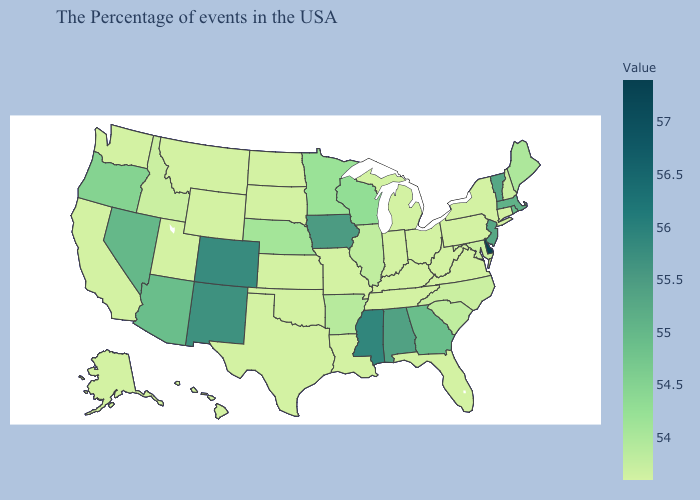Among the states that border Kansas , does Missouri have the highest value?
Write a very short answer. No. Among the states that border Delaware , does New Jersey have the lowest value?
Short answer required. No. Which states have the lowest value in the USA?
Concise answer only. Connecticut, New York, Pennsylvania, Virginia, West Virginia, Ohio, Florida, Michigan, Kentucky, Indiana, Tennessee, Louisiana, Missouri, Kansas, Oklahoma, Texas, South Dakota, North Dakota, Wyoming, Utah, Montana, California, Washington, Alaska, Hawaii. Does Michigan have the lowest value in the USA?
Write a very short answer. Yes. Does Arkansas have the highest value in the USA?
Keep it brief. No. Among the states that border Maryland , which have the lowest value?
Keep it brief. Pennsylvania, Virginia, West Virginia. 